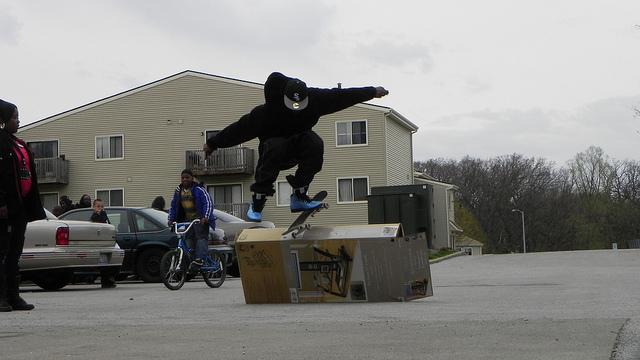Who is riding a bike?
Write a very short answer. Boy. Is the boy on a skateboard?
Give a very brief answer. Yes. Do you like this house?
Write a very short answer. Yes. 